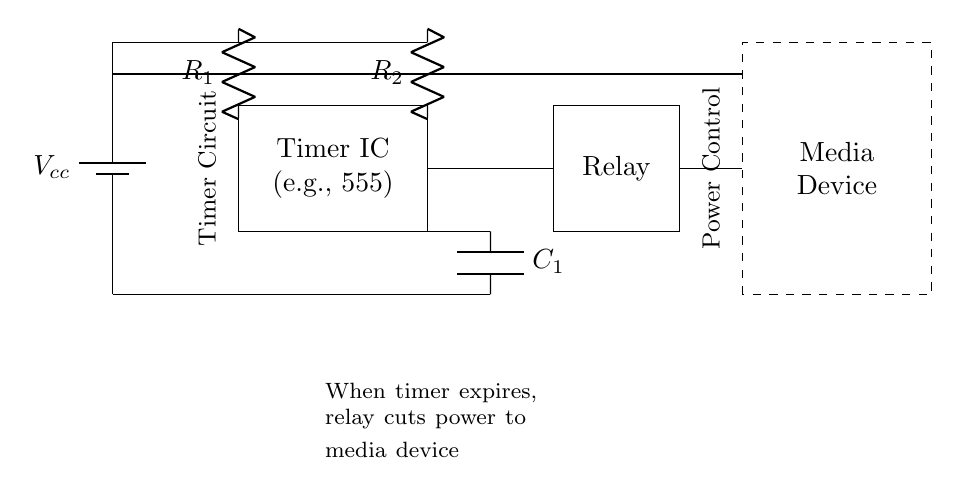What type of circuit is this? This circuit is a timer circuit, indicated by the presence of a timer IC and its associated components. The timer controls the operation of a relay that cuts power to a media device after a set duration.
Answer: timer circuit What component cuts power to the media device? The component that cuts power to the media device is the relay. The relay is activated by the timer and is responsible for controlling the power supply to the media device once the timer expires.
Answer: relay What is the function of the capacitor in this circuit? The capacitor in this circuit (C1) is part of the timing mechanism that determines how long the timer will run before it triggers the relay to cut power. It works together with the resistors to set the timing interval.
Answer: timing mechanism Which component provides the power supply? The power supply is provided by the battery, marked as Vcc in the diagram. It is the source of voltage that powers the entire circuit, including the timer and the relay.
Answer: battery When does the relay activate? The relay activates when the timer reaches its preset time limit, which is determined by the resistors and capacitor connected to the timer IC. This activation subsequently cuts off power to the media device.
Answer: timer expiration How many resistors are present in the circuit? There are two resistors in the circuit, labeled R1 and R2. They are crucial for determining the timing characteristics of the circuit when used with the capacitor.
Answer: two 